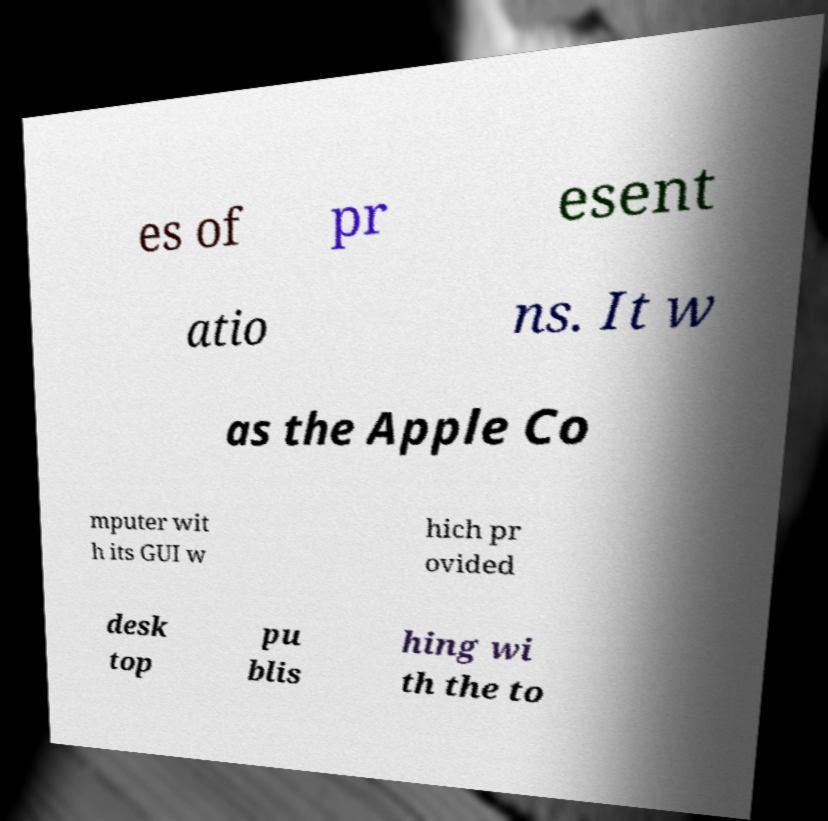Please identify and transcribe the text found in this image. es of pr esent atio ns. It w as the Apple Co mputer wit h its GUI w hich pr ovided desk top pu blis hing wi th the to 